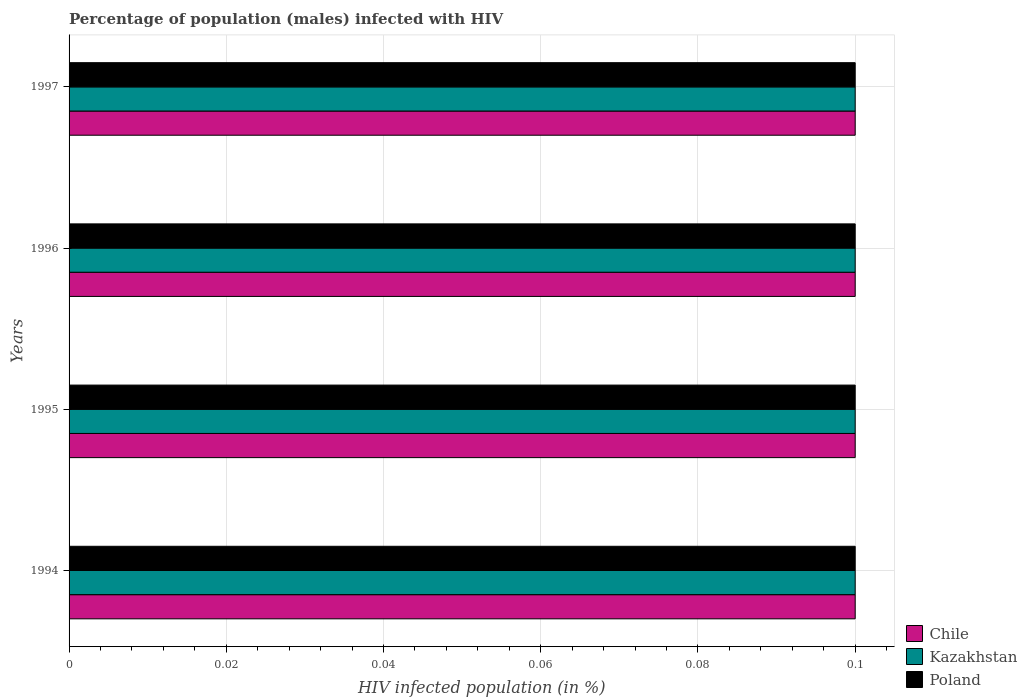Are the number of bars on each tick of the Y-axis equal?
Your answer should be very brief. Yes. How many bars are there on the 2nd tick from the top?
Give a very brief answer. 3. In how many cases, is the number of bars for a given year not equal to the number of legend labels?
Give a very brief answer. 0. Across all years, what is the maximum percentage of HIV infected male population in Chile?
Make the answer very short. 0.1. Across all years, what is the minimum percentage of HIV infected male population in Chile?
Your answer should be compact. 0.1. In which year was the percentage of HIV infected male population in Chile maximum?
Your answer should be very brief. 1994. In which year was the percentage of HIV infected male population in Poland minimum?
Your answer should be very brief. 1994. What is the difference between the percentage of HIV infected male population in Kazakhstan in 1995 and the percentage of HIV infected male population in Poland in 1997?
Offer a terse response. 0. What is the average percentage of HIV infected male population in Kazakhstan per year?
Provide a succinct answer. 0.1. What is the ratio of the percentage of HIV infected male population in Chile in 1994 to that in 1996?
Keep it short and to the point. 1. Is the difference between the percentage of HIV infected male population in Kazakhstan in 1994 and 1995 greater than the difference between the percentage of HIV infected male population in Poland in 1994 and 1995?
Your answer should be compact. No. What is the difference between the highest and the second highest percentage of HIV infected male population in Chile?
Make the answer very short. 0. What is the difference between the highest and the lowest percentage of HIV infected male population in Chile?
Provide a short and direct response. 0. In how many years, is the percentage of HIV infected male population in Poland greater than the average percentage of HIV infected male population in Poland taken over all years?
Provide a short and direct response. 0. Is the sum of the percentage of HIV infected male population in Poland in 1994 and 1997 greater than the maximum percentage of HIV infected male population in Chile across all years?
Offer a terse response. Yes. What does the 1st bar from the top in 1997 represents?
Your answer should be very brief. Poland. What does the 2nd bar from the bottom in 1996 represents?
Ensure brevity in your answer.  Kazakhstan. How many bars are there?
Your answer should be compact. 12. How many years are there in the graph?
Offer a terse response. 4. What is the difference between two consecutive major ticks on the X-axis?
Give a very brief answer. 0.02. Does the graph contain any zero values?
Your answer should be compact. No. Where does the legend appear in the graph?
Give a very brief answer. Bottom right. What is the title of the graph?
Provide a short and direct response. Percentage of population (males) infected with HIV. What is the label or title of the X-axis?
Give a very brief answer. HIV infected population (in %). What is the HIV infected population (in %) in Chile in 1994?
Make the answer very short. 0.1. What is the HIV infected population (in %) of Chile in 1995?
Your answer should be compact. 0.1. What is the HIV infected population (in %) of Kazakhstan in 1995?
Your answer should be very brief. 0.1. What is the HIV infected population (in %) of Kazakhstan in 1996?
Ensure brevity in your answer.  0.1. What is the HIV infected population (in %) in Poland in 1996?
Your answer should be very brief. 0.1. What is the HIV infected population (in %) in Chile in 1997?
Ensure brevity in your answer.  0.1. What is the HIV infected population (in %) of Poland in 1997?
Your answer should be very brief. 0.1. Across all years, what is the maximum HIV infected population (in %) in Kazakhstan?
Offer a terse response. 0.1. Across all years, what is the minimum HIV infected population (in %) in Poland?
Ensure brevity in your answer.  0.1. What is the total HIV infected population (in %) of Kazakhstan in the graph?
Your answer should be compact. 0.4. What is the difference between the HIV infected population (in %) of Chile in 1994 and that in 1995?
Your response must be concise. 0. What is the difference between the HIV infected population (in %) of Kazakhstan in 1994 and that in 1995?
Ensure brevity in your answer.  0. What is the difference between the HIV infected population (in %) of Chile in 1994 and that in 1996?
Your response must be concise. 0. What is the difference between the HIV infected population (in %) in Kazakhstan in 1994 and that in 1996?
Provide a short and direct response. 0. What is the difference between the HIV infected population (in %) in Kazakhstan in 1994 and that in 1997?
Your answer should be very brief. 0. What is the difference between the HIV infected population (in %) of Poland in 1994 and that in 1997?
Give a very brief answer. 0. What is the difference between the HIV infected population (in %) of Chile in 1995 and that in 1996?
Your answer should be very brief. 0. What is the difference between the HIV infected population (in %) in Chile in 1995 and that in 1997?
Offer a terse response. 0. What is the difference between the HIV infected population (in %) of Kazakhstan in 1995 and that in 1997?
Offer a very short reply. 0. What is the difference between the HIV infected population (in %) in Chile in 1996 and that in 1997?
Provide a short and direct response. 0. What is the difference between the HIV infected population (in %) in Kazakhstan in 1996 and that in 1997?
Provide a succinct answer. 0. What is the difference between the HIV infected population (in %) in Poland in 1996 and that in 1997?
Offer a terse response. 0. What is the difference between the HIV infected population (in %) in Chile in 1994 and the HIV infected population (in %) in Kazakhstan in 1995?
Your response must be concise. 0. What is the difference between the HIV infected population (in %) in Chile in 1994 and the HIV infected population (in %) in Poland in 1995?
Offer a very short reply. 0. What is the difference between the HIV infected population (in %) in Chile in 1994 and the HIV infected population (in %) in Kazakhstan in 1996?
Your answer should be compact. 0. What is the difference between the HIV infected population (in %) in Chile in 1994 and the HIV infected population (in %) in Kazakhstan in 1997?
Keep it short and to the point. 0. What is the difference between the HIV infected population (in %) in Kazakhstan in 1994 and the HIV infected population (in %) in Poland in 1997?
Keep it short and to the point. 0. What is the difference between the HIV infected population (in %) of Chile in 1995 and the HIV infected population (in %) of Kazakhstan in 1997?
Provide a succinct answer. 0. What is the difference between the HIV infected population (in %) of Chile in 1996 and the HIV infected population (in %) of Kazakhstan in 1997?
Provide a short and direct response. 0. What is the difference between the HIV infected population (in %) of Kazakhstan in 1996 and the HIV infected population (in %) of Poland in 1997?
Offer a terse response. 0. What is the average HIV infected population (in %) in Poland per year?
Offer a terse response. 0.1. In the year 1994, what is the difference between the HIV infected population (in %) of Chile and HIV infected population (in %) of Kazakhstan?
Offer a terse response. 0. In the year 1994, what is the difference between the HIV infected population (in %) of Chile and HIV infected population (in %) of Poland?
Provide a succinct answer. 0. In the year 1994, what is the difference between the HIV infected population (in %) of Kazakhstan and HIV infected population (in %) of Poland?
Your answer should be compact. 0. In the year 1996, what is the difference between the HIV infected population (in %) of Chile and HIV infected population (in %) of Poland?
Provide a short and direct response. 0. In the year 1996, what is the difference between the HIV infected population (in %) of Kazakhstan and HIV infected population (in %) of Poland?
Keep it short and to the point. 0. In the year 1997, what is the difference between the HIV infected population (in %) in Chile and HIV infected population (in %) in Kazakhstan?
Give a very brief answer. 0. In the year 1997, what is the difference between the HIV infected population (in %) in Kazakhstan and HIV infected population (in %) in Poland?
Provide a short and direct response. 0. What is the ratio of the HIV infected population (in %) of Chile in 1994 to that in 1996?
Provide a short and direct response. 1. What is the ratio of the HIV infected population (in %) in Poland in 1994 to that in 1996?
Make the answer very short. 1. What is the ratio of the HIV infected population (in %) in Chile in 1994 to that in 1997?
Ensure brevity in your answer.  1. What is the ratio of the HIV infected population (in %) in Kazakhstan in 1994 to that in 1997?
Provide a short and direct response. 1. What is the ratio of the HIV infected population (in %) in Chile in 1995 to that in 1996?
Provide a succinct answer. 1. What is the ratio of the HIV infected population (in %) of Poland in 1995 to that in 1996?
Offer a very short reply. 1. What is the ratio of the HIV infected population (in %) of Chile in 1996 to that in 1997?
Give a very brief answer. 1. What is the ratio of the HIV infected population (in %) in Kazakhstan in 1996 to that in 1997?
Make the answer very short. 1. What is the ratio of the HIV infected population (in %) in Poland in 1996 to that in 1997?
Keep it short and to the point. 1. What is the difference between the highest and the second highest HIV infected population (in %) in Chile?
Ensure brevity in your answer.  0. What is the difference between the highest and the second highest HIV infected population (in %) of Kazakhstan?
Offer a very short reply. 0. What is the difference between the highest and the second highest HIV infected population (in %) in Poland?
Provide a succinct answer. 0. What is the difference between the highest and the lowest HIV infected population (in %) of Chile?
Your answer should be very brief. 0. What is the difference between the highest and the lowest HIV infected population (in %) in Kazakhstan?
Provide a succinct answer. 0. 